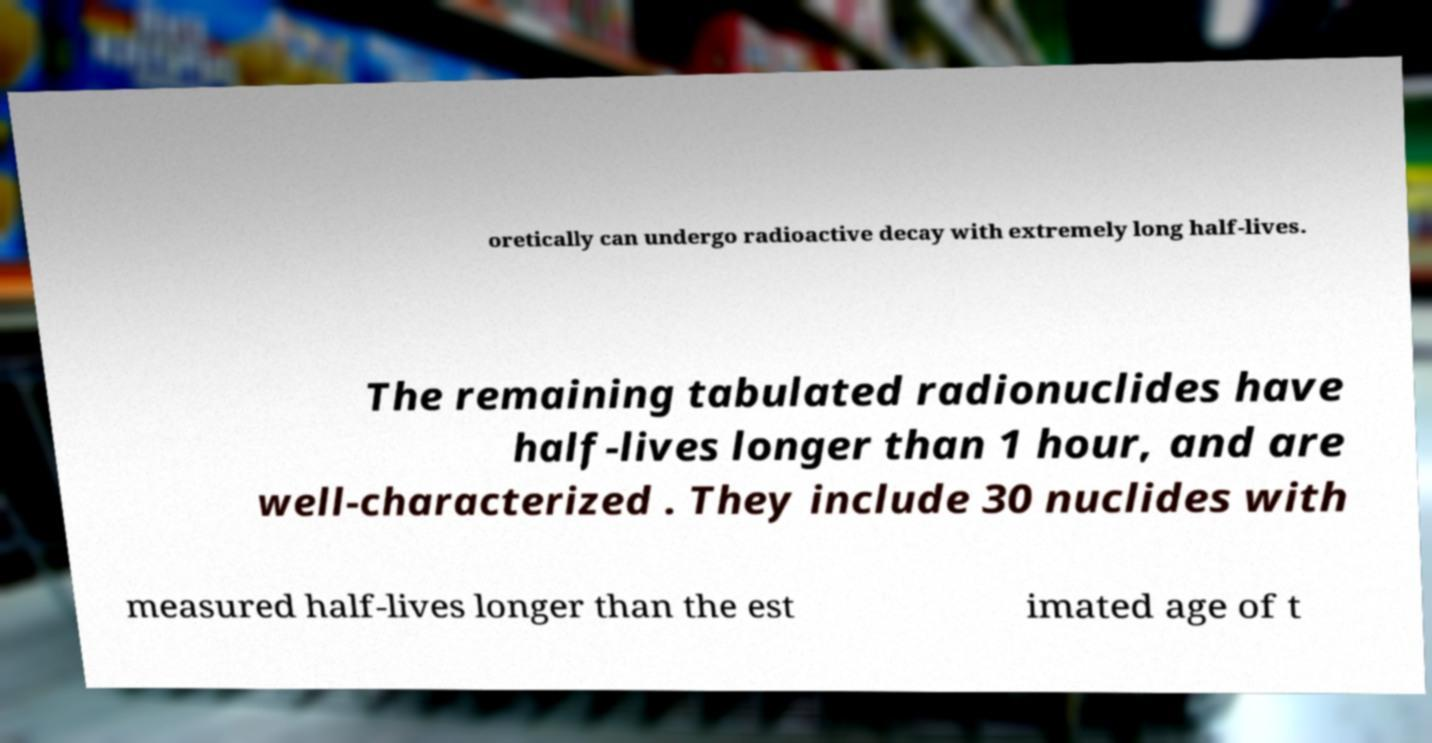Could you extract and type out the text from this image? oretically can undergo radioactive decay with extremely long half-lives. The remaining tabulated radionuclides have half-lives longer than 1 hour, and are well-characterized . They include 30 nuclides with measured half-lives longer than the est imated age of t 